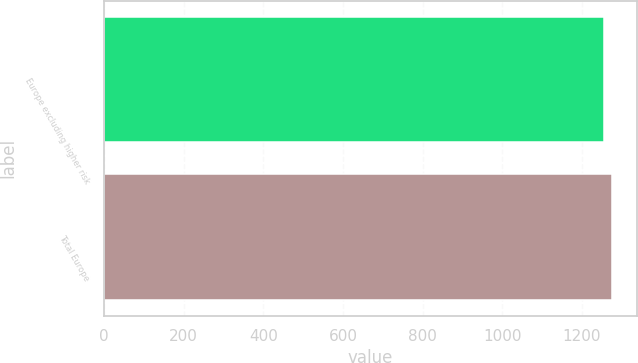Convert chart. <chart><loc_0><loc_0><loc_500><loc_500><bar_chart><fcel>Europe excluding higher risk<fcel>Total Europe<nl><fcel>1255<fcel>1275<nl></chart> 